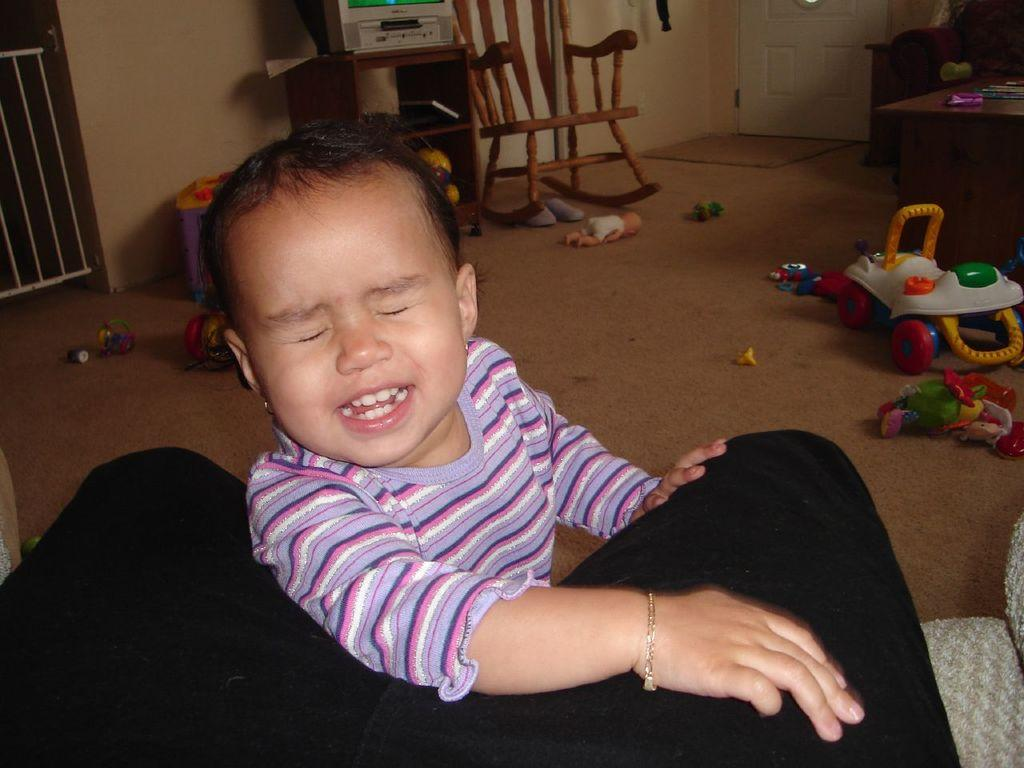Who is present in the image? There is a girl in the image. What is the girl doing in the image? The girl is smiling in the image. What can be seen on the floor in the image? There are toys on the floor in the image. What piece of furniture is in the image? There is a chair in the image. Where is the door located in the image? The door is on the right side of the image. What type of birds can be seen flying through the room in the image? There are no birds visible in the image; it features a girl, toys, a chair, and a door. What kind of trains can be seen on the floor in the image? There are no trains visible in the image; it features toys, but no trains are mentioned in the provided facts. 